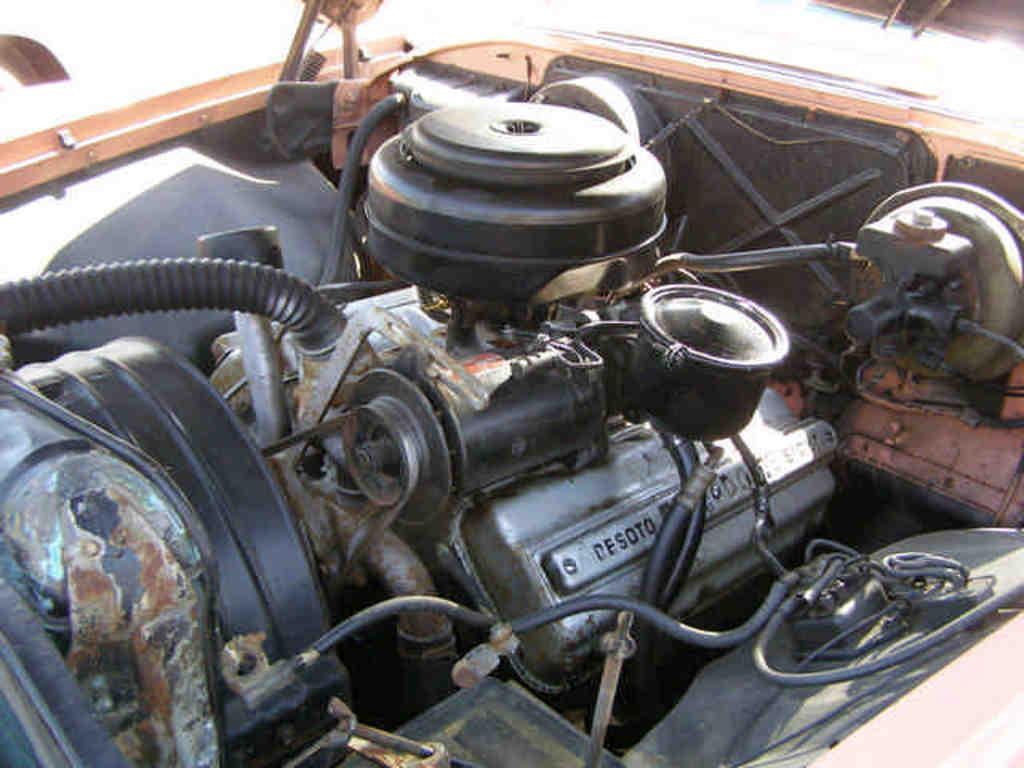How would you summarize this image in a sentence or two? This picture contains an engine of the car. In this picture, we see some inner parts of the car. In the background, it is white in color. It might be a sunny day. 